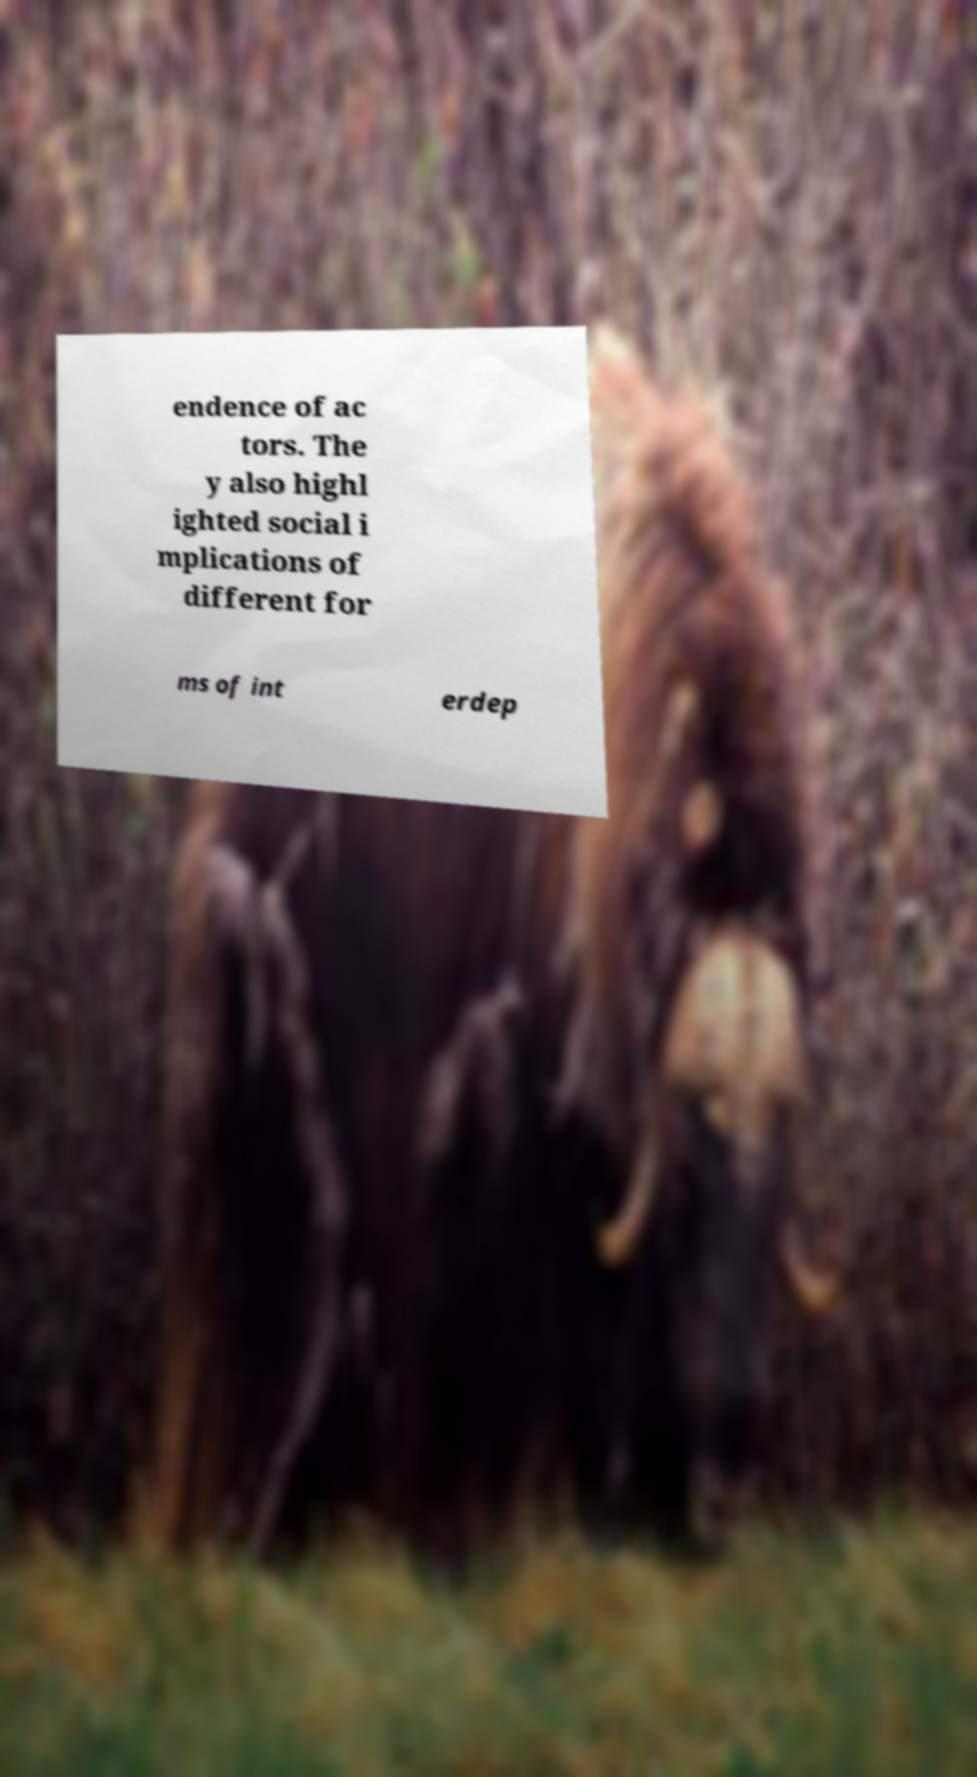Could you assist in decoding the text presented in this image and type it out clearly? endence of ac tors. The y also highl ighted social i mplications of different for ms of int erdep 